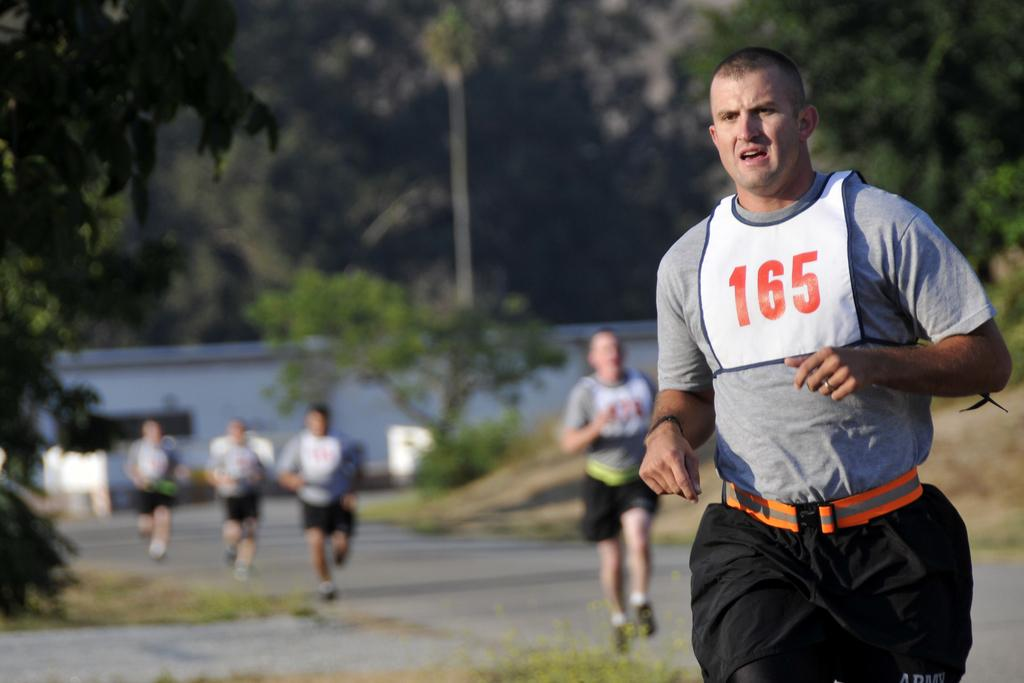What is happening in the image involving a group of people? The people in the image are running on the road. What can be seen in the background of the image? There is a building and trees visible in the background. What type of surface are the people running on? The people are running on a road. What else can be seen in the image besides the people and the road? There is grass visible in the image. What type of badge is the dog wearing in the image? There is no dog present in the image, so there is no badge to be seen. 